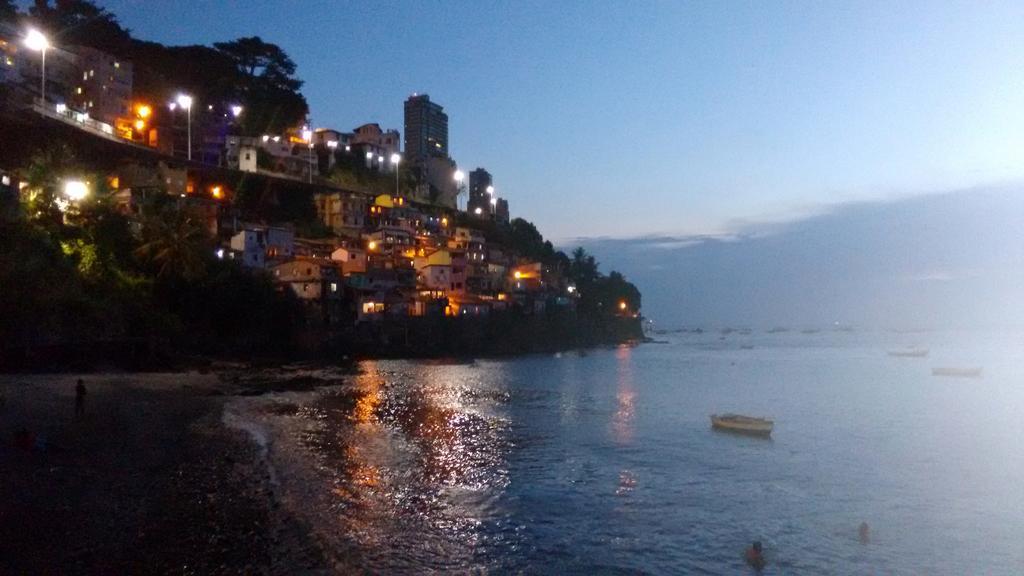How would you summarize this image in a sentence or two? This picture is clicked outside the city. In the foreground we can see the water body and there are some persons and boats in the water body. On the left we can see the trees and buildings and lights. In the background there is a sky. 